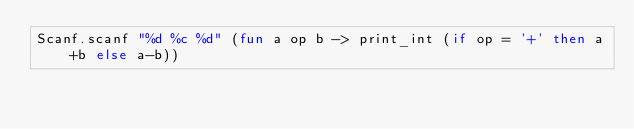<code> <loc_0><loc_0><loc_500><loc_500><_OCaml_>Scanf.scanf "%d %c %d" (fun a op b -> print_int (if op = '+' then a+b else a-b))</code> 